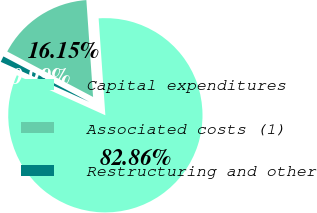<chart> <loc_0><loc_0><loc_500><loc_500><pie_chart><fcel>Capital expenditures<fcel>Associated costs (1)<fcel>Restructuring and other<nl><fcel>82.86%<fcel>16.15%<fcel>0.99%<nl></chart> 